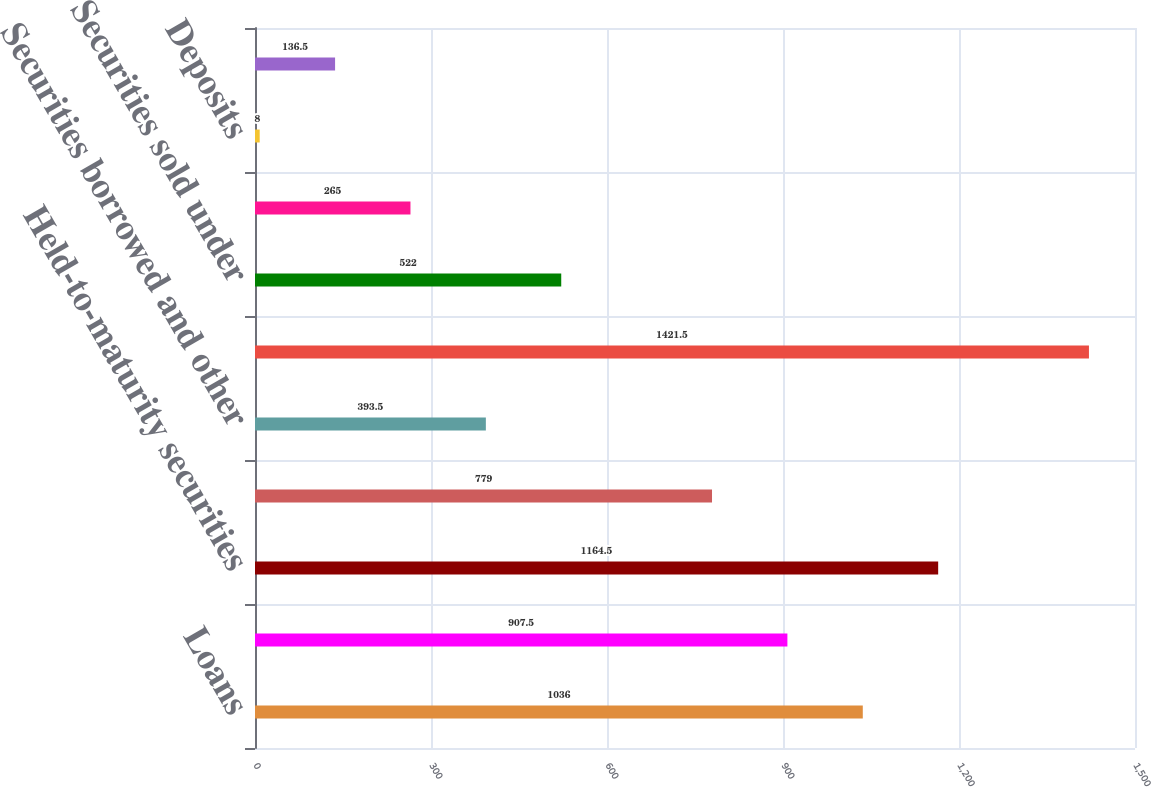Convert chart. <chart><loc_0><loc_0><loc_500><loc_500><bar_chart><fcel>Loans<fcel>Available-for-sale securities<fcel>Held-to-maturity securities<fcel>Margin receivables<fcel>Securities borrowed and other<fcel>Total operating interest<fcel>Securities sold under<fcel>FHLB advances and other<fcel>Deposits<fcel>Customer payables and other<nl><fcel>1036<fcel>907.5<fcel>1164.5<fcel>779<fcel>393.5<fcel>1421.5<fcel>522<fcel>265<fcel>8<fcel>136.5<nl></chart> 